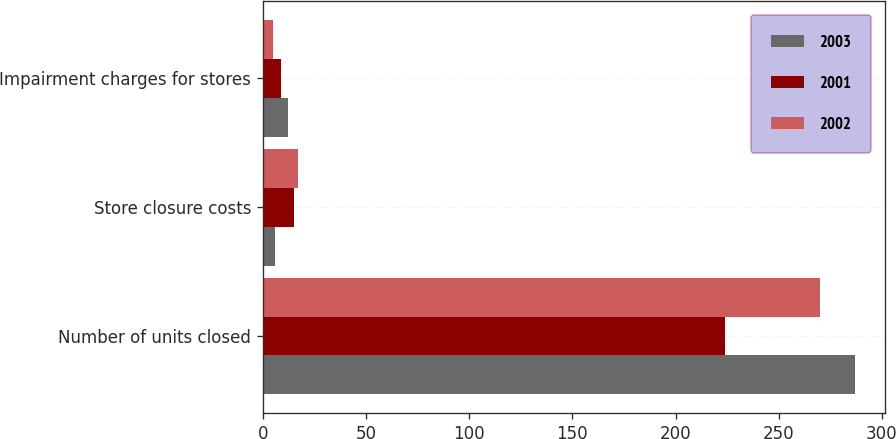Convert chart to OTSL. <chart><loc_0><loc_0><loc_500><loc_500><stacked_bar_chart><ecel><fcel>Number of units closed<fcel>Store closure costs<fcel>Impairment charges for stores<nl><fcel>2003<fcel>287<fcel>6<fcel>12<nl><fcel>2001<fcel>224<fcel>15<fcel>9<nl><fcel>2002<fcel>270<fcel>17<fcel>5<nl></chart> 